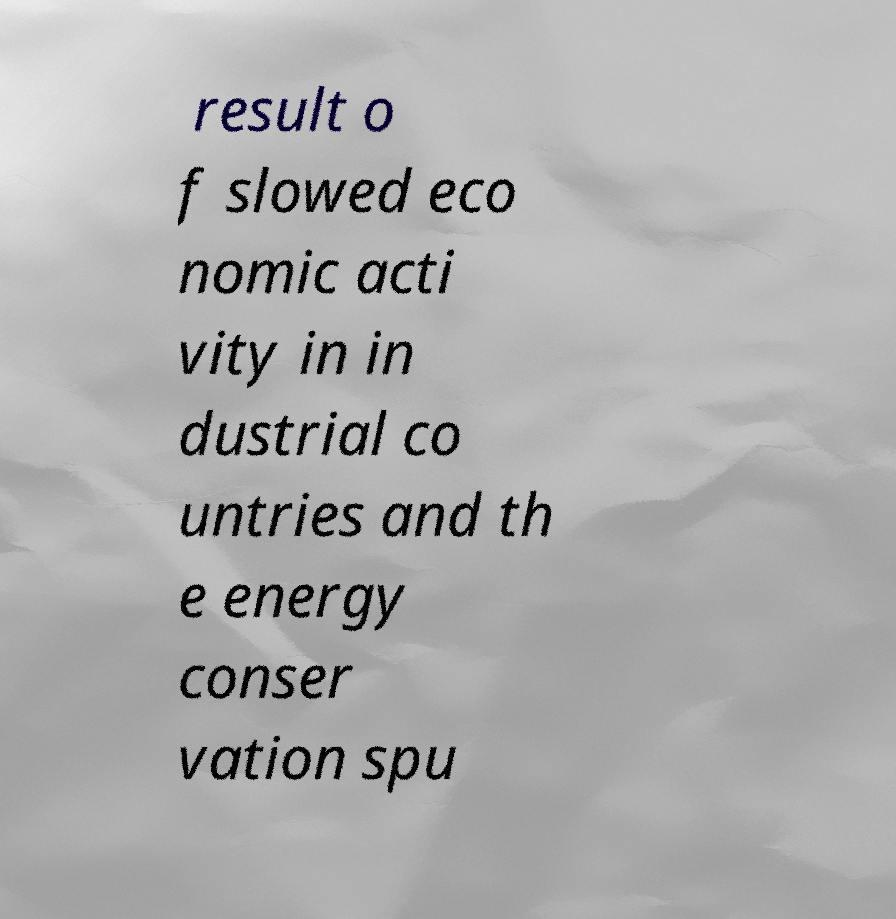For documentation purposes, I need the text within this image transcribed. Could you provide that? result o f slowed eco nomic acti vity in in dustrial co untries and th e energy conser vation spu 